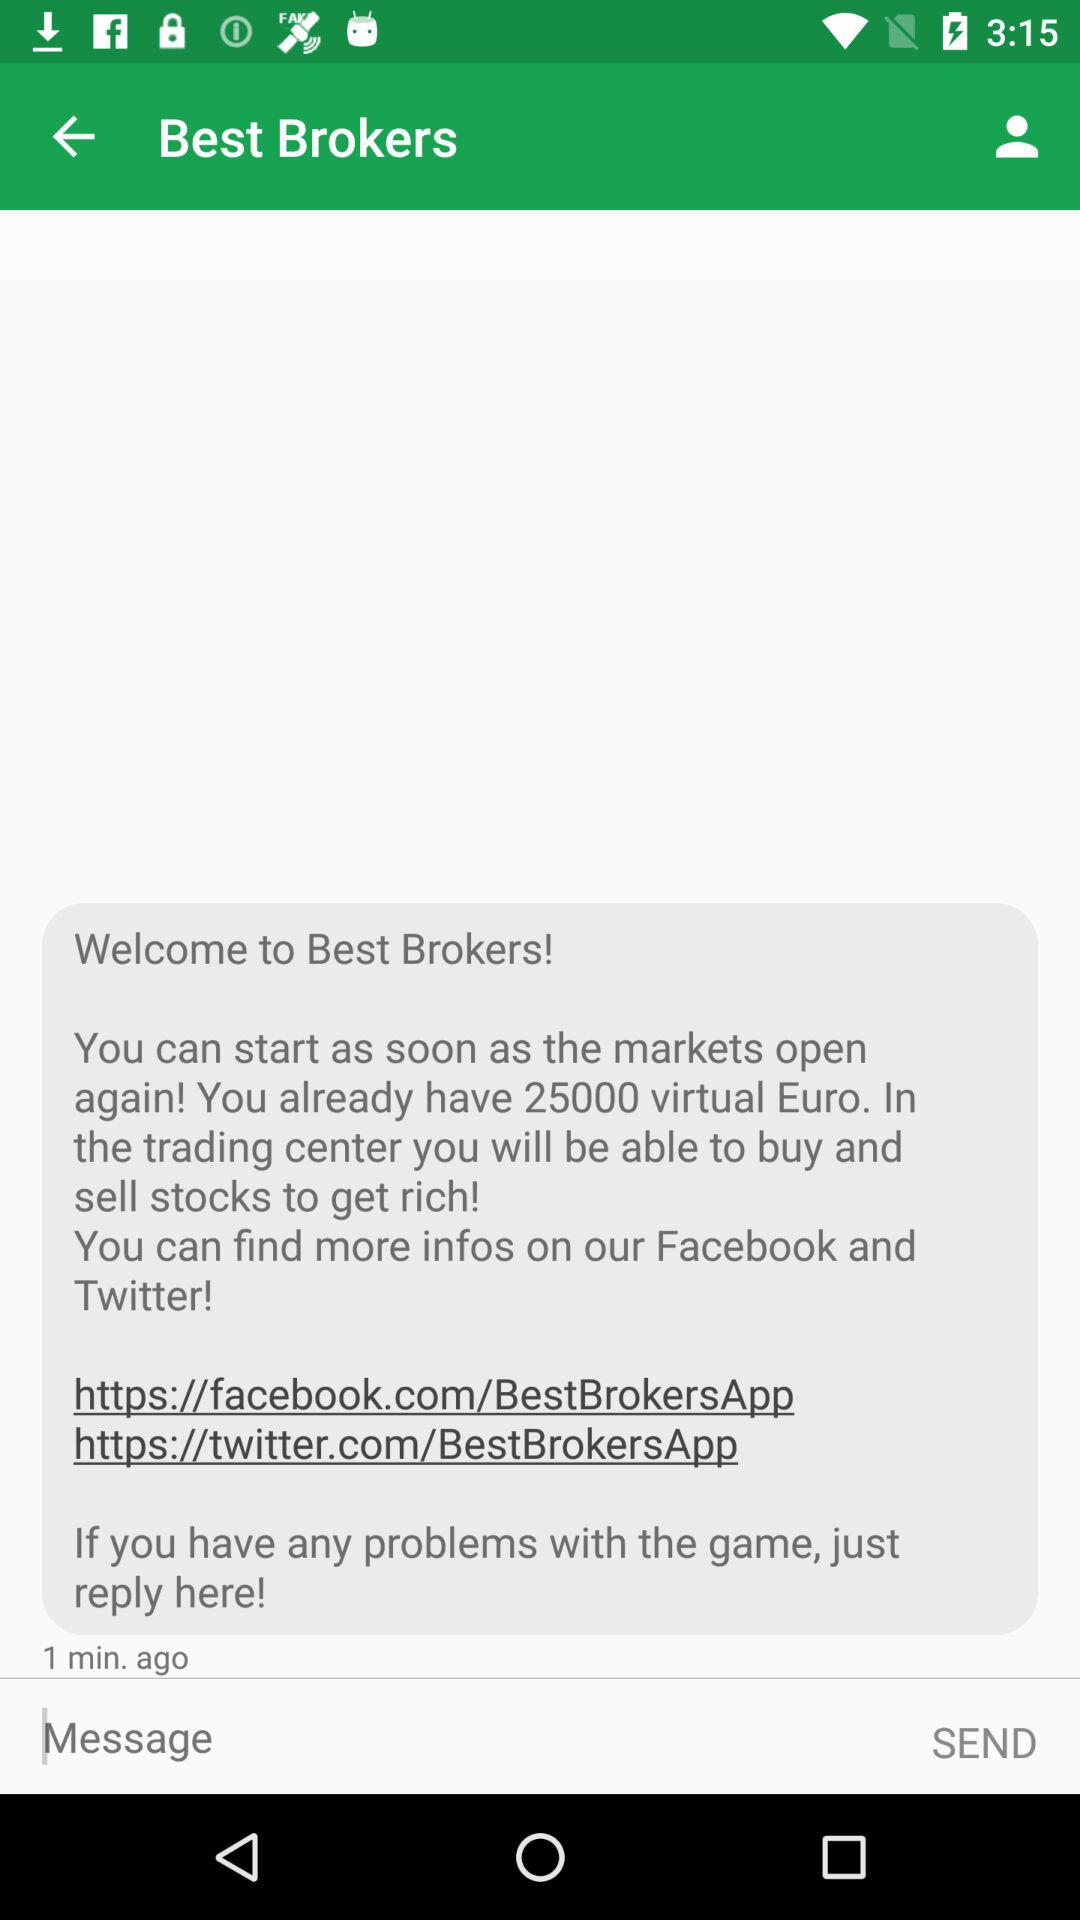How many virtual euros do I have?
Answer the question using a single word or phrase. 25000 